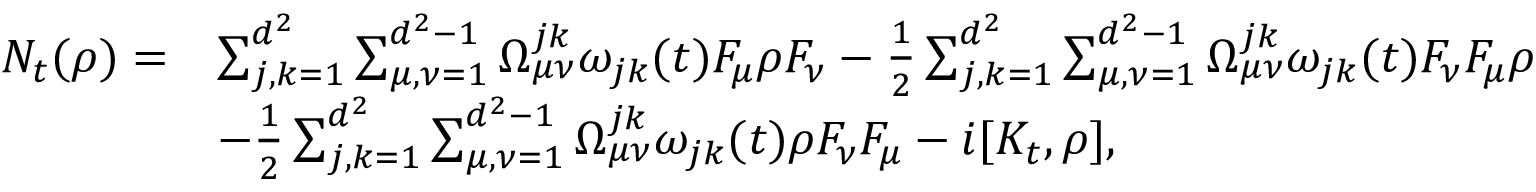<formula> <loc_0><loc_0><loc_500><loc_500>\begin{array} { r l } { N _ { t } ( \rho ) = } & { \sum _ { j , k = 1 } ^ { d ^ { 2 } } \sum _ { \mu , \nu = 1 } ^ { d ^ { 2 } - 1 } \Omega _ { \mu \nu } ^ { j k } \omega _ { j k } ( t ) F _ { \mu } \rho F _ { \nu } - \frac { 1 } { 2 } \sum _ { j , k = 1 } ^ { d ^ { 2 } } \sum _ { \mu , \nu = 1 } ^ { d ^ { 2 } - 1 } \Omega _ { \mu \nu } ^ { j k } \omega _ { j k } ( t ) F _ { \nu } F _ { \mu } \rho } \\ & { - \frac { 1 } { 2 } \sum _ { j , k = 1 } ^ { d ^ { 2 } } \sum _ { \mu , \nu = 1 } ^ { d ^ { 2 } - 1 } \Omega _ { \mu \nu } ^ { j k } \omega _ { j k } ( t ) \rho F _ { \nu } F _ { \mu } - i [ K _ { t } , \rho ] , } \end{array}</formula> 